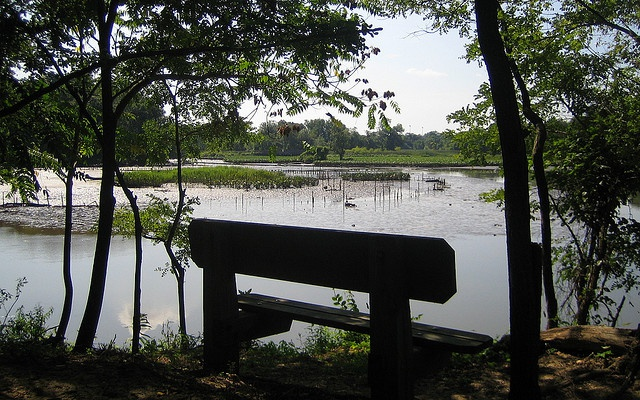Describe the objects in this image and their specific colors. I can see a bench in black, darkgray, gray, and navy tones in this image. 